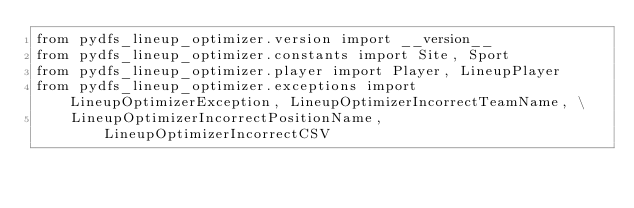<code> <loc_0><loc_0><loc_500><loc_500><_Python_>from pydfs_lineup_optimizer.version import __version__
from pydfs_lineup_optimizer.constants import Site, Sport
from pydfs_lineup_optimizer.player import Player, LineupPlayer
from pydfs_lineup_optimizer.exceptions import LineupOptimizerException, LineupOptimizerIncorrectTeamName, \
    LineupOptimizerIncorrectPositionName, LineupOptimizerIncorrectCSV</code> 